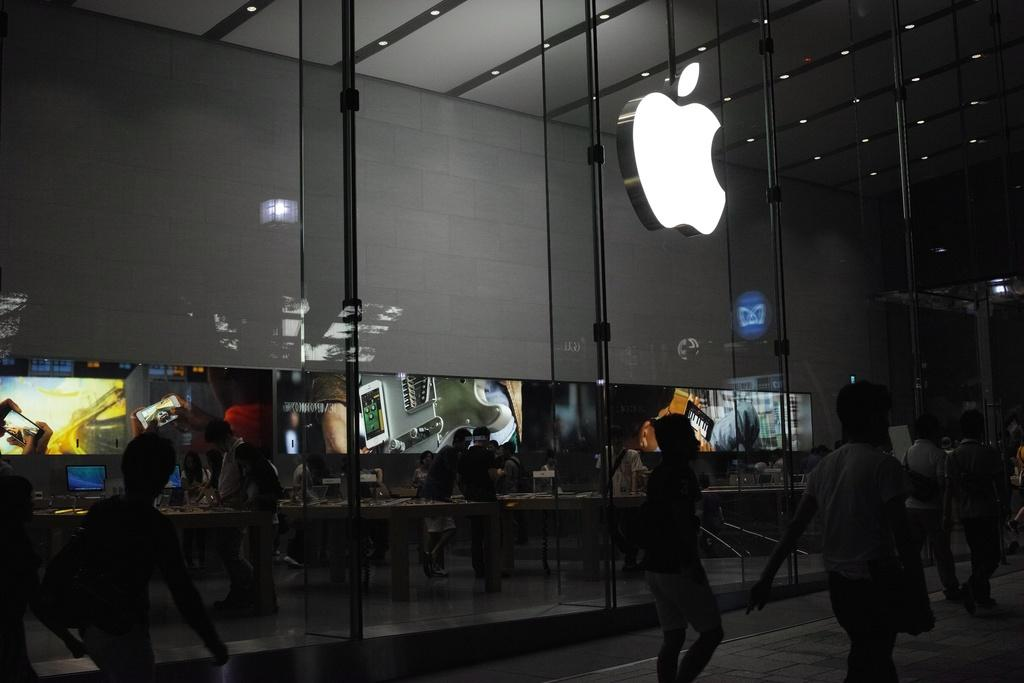How many persons can be seen in the image? There are persons standing in the image. What surface are the persons standing on? The persons are standing on the floor. What furniture is present in the image? Tables are present in the image. What is on top of the tables? Desktops are on the tables, and there are electronics on the tables. What can be seen on the wall in the image? Display screens are visible on the wall. What type of story is being told by the bear in the image? There is no bear present in the image, so no story is being told by a bear. 